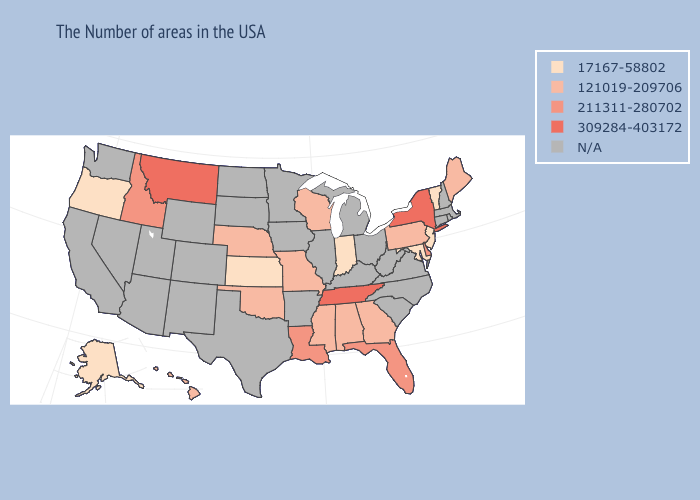Name the states that have a value in the range N/A?
Short answer required. Massachusetts, Rhode Island, New Hampshire, Connecticut, Virginia, North Carolina, South Carolina, West Virginia, Ohio, Michigan, Kentucky, Illinois, Arkansas, Minnesota, Iowa, Texas, South Dakota, North Dakota, Wyoming, Colorado, New Mexico, Utah, Arizona, Nevada, California, Washington. Does New York have the highest value in the Northeast?
Give a very brief answer. Yes. Which states have the lowest value in the West?
Keep it brief. Oregon, Alaska. What is the value of Arkansas?
Give a very brief answer. N/A. Does the map have missing data?
Be succinct. Yes. What is the lowest value in the USA?
Write a very short answer. 17167-58802. What is the lowest value in the South?
Quick response, please. 17167-58802. Does Oregon have the lowest value in the USA?
Write a very short answer. Yes. Which states have the lowest value in the South?
Keep it brief. Maryland. Name the states that have a value in the range 121019-209706?
Short answer required. Maine, Pennsylvania, Georgia, Alabama, Wisconsin, Mississippi, Missouri, Nebraska, Oklahoma, Hawaii. What is the highest value in the West ?
Write a very short answer. 309284-403172. What is the highest value in states that border Minnesota?
Be succinct. 121019-209706. Which states have the lowest value in the Northeast?
Concise answer only. Vermont, New Jersey. 